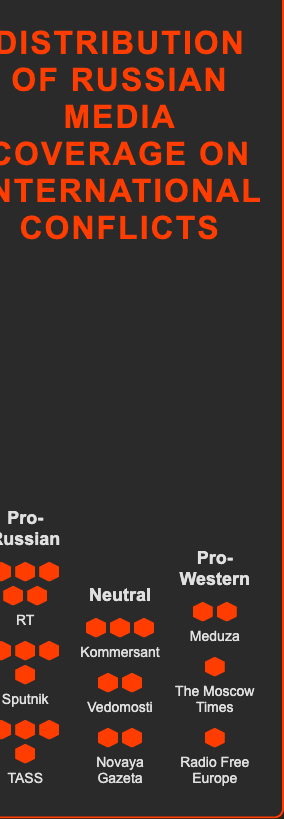Which alignment group has the highest total coverage units? The Pro-Russian group has the highest total coverage units. Adding up the coverage units from RT (25), Sputnik (20), and TASS (18) gives a total of 63 units.
Answer: Pro-Russian What is the total coverage unit for Pro-Western alignment? Adding the coverage units for Meduza (6), The Moscow Times (5), and Radio Free Europe (4) gives a total of 15 units.
Answer: 15 Which media outlet has the highest individual coverage units? RT has the highest individual coverage units with 25 units.
Answer: RT Compare the coverage units of Sputnik and Kommersant. Which one is higher and by how much? Sputnik has 20 units and Kommersant has 12 units. Subtracting 12 from 20, Sputnik has 8 more coverage units than Kommersant.
Answer: Sputnik by 8 units What is the average coverage units for the Neutral alignment? The Neutral alignment includes Kommersant (12), Vedomosti (10), and Novaya Gazeta (8). Summing these gives 30, and dividing by 3 (the number of media outlets) results in an average of 10 units.
Answer: 10 Which alignment group has the least total coverage units? The Pro-Western alignment has the least total coverage units. Adding Meduza (6), The Moscow Times (5), and Radio Free Europe (4) gives a total of 15 units.
Answer: Pro-Western What is the total coverage units for all media outlets combined? Adding the total coverage units of Pro-Russian (63), Neutral (30), and Pro-Western (15) gives 108 units in total.
Answer: 108 Does any media outlet in the Neutral alignment cover less than 10 units? If yes, which one(s)? Yes, Novaya Gazeta covers 8 units, which is less than 10 units.
Answer: Novaya Gazeta How many more coverage units does the Pro-Russian alignment have compared to the Pro-Western alignment? The Pro-Russian alignment has 63 units and the Pro-Western alignment has 15 units. Subtracting 15 from 63 gives 48 more units.
Answer: 48 